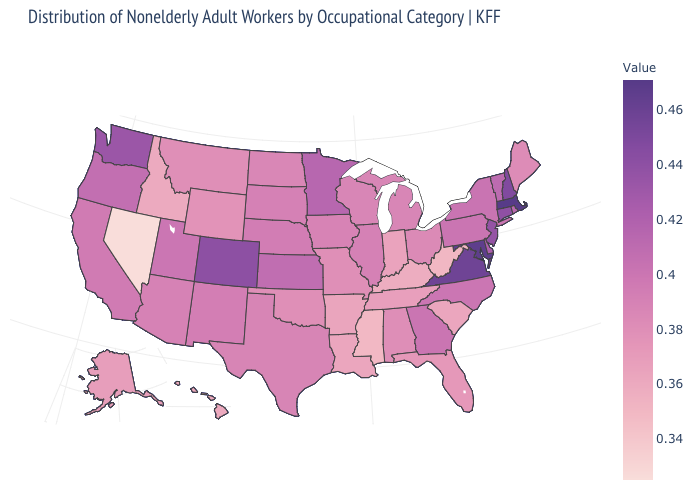Which states have the lowest value in the MidWest?
Be succinct. Indiana. Does the map have missing data?
Concise answer only. No. Does Georgia have a lower value than Colorado?
Keep it brief. Yes. Which states hav the highest value in the South?
Be succinct. Maryland. Which states hav the highest value in the South?
Give a very brief answer. Maryland. Among the states that border Alabama , does Tennessee have the highest value?
Give a very brief answer. No. 